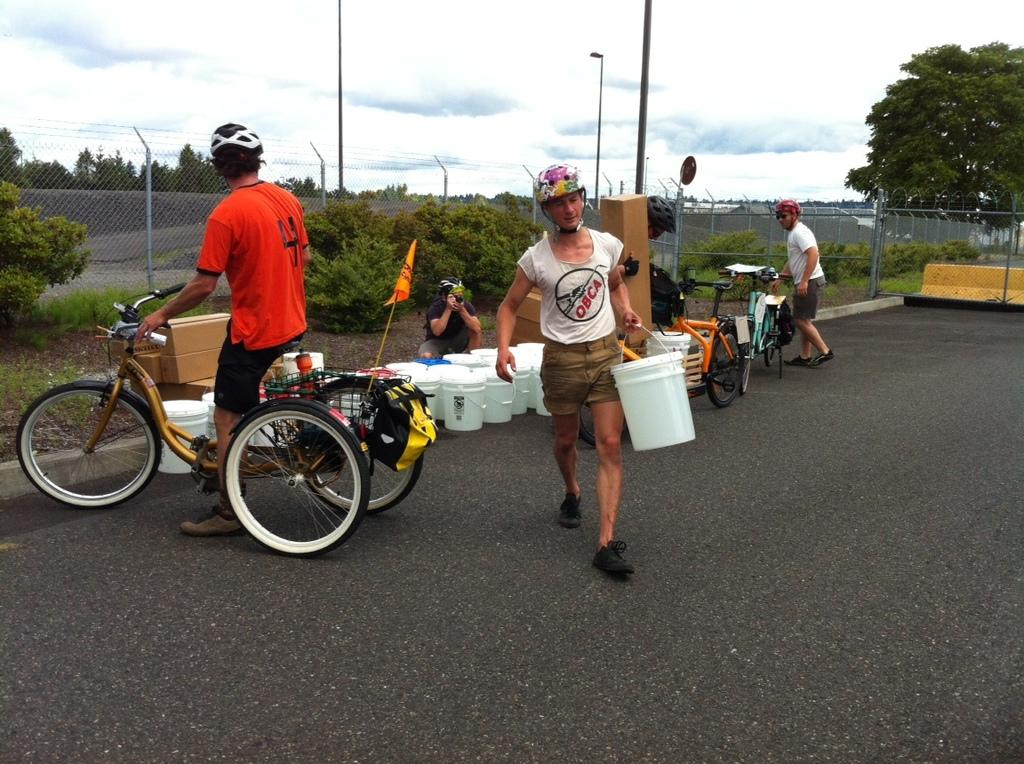Who is present in the image? There is a woman and a man in the image. What is the woman holding in her hand? The woman is carrying an object in her hand. What is the man doing in the image? The man is holding a bicycle. What can be seen in the background of the image? There are trees in the background of the image. What is the condition of the sky in the image? The sky is clear in the image. What type of bread can be seen on the woman's nose in the image? There is no bread present on the woman's nose in the image. What is the relation between the woman and the man in the image? The provided facts do not give any information about the relationship between the woman and the man in the image. 